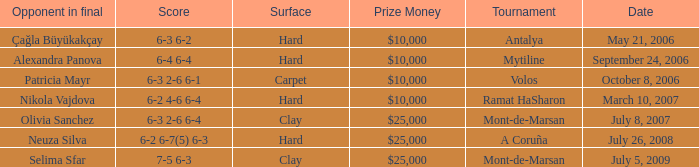Who was the opponent on carpet in a final? Patricia Mayr. 